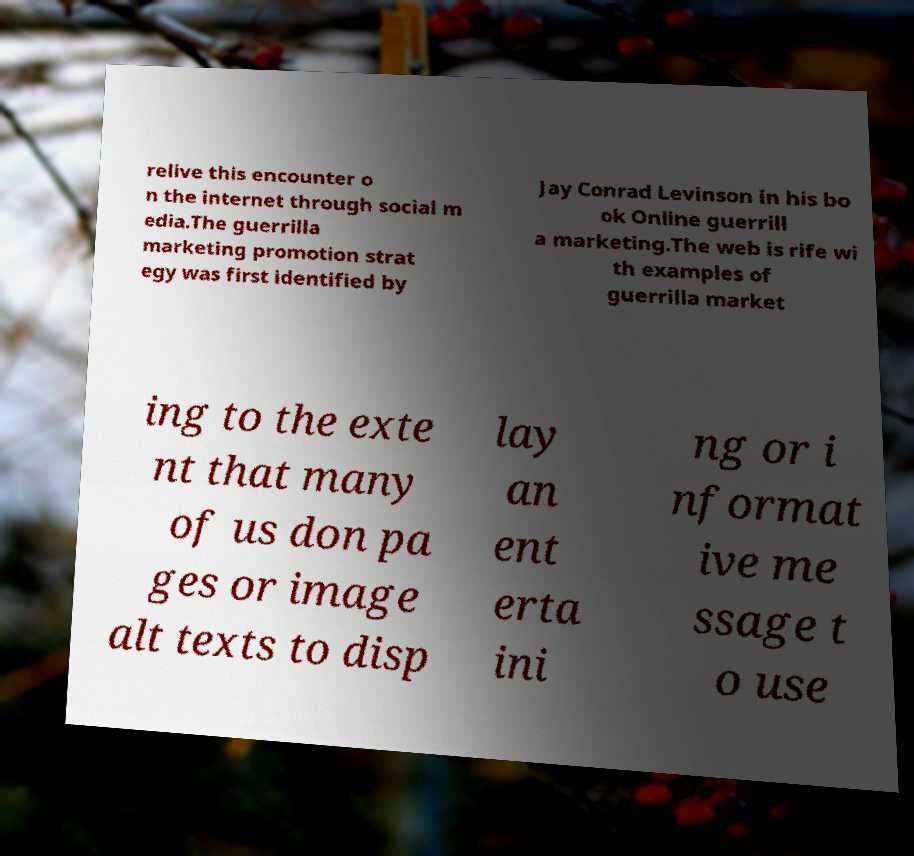Please read and relay the text visible in this image. What does it say? relive this encounter o n the internet through social m edia.The guerrilla marketing promotion strat egy was first identified by Jay Conrad Levinson in his bo ok Online guerrill a marketing.The web is rife wi th examples of guerrilla market ing to the exte nt that many of us don pa ges or image alt texts to disp lay an ent erta ini ng or i nformat ive me ssage t o use 